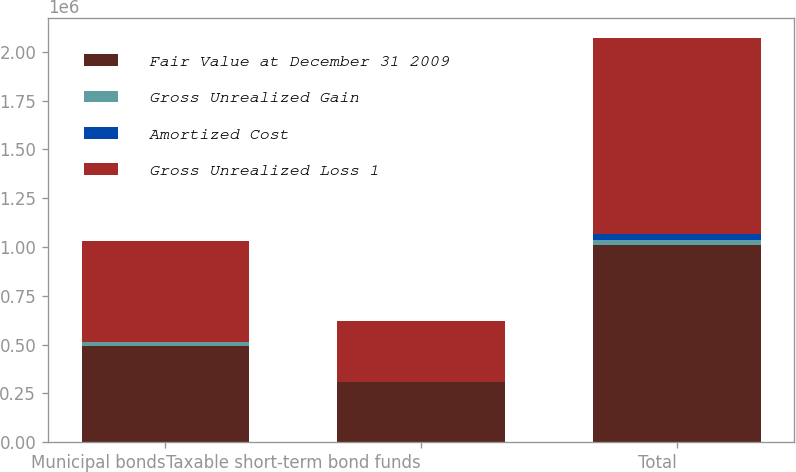Convert chart. <chart><loc_0><loc_0><loc_500><loc_500><stacked_bar_chart><ecel><fcel>Municipal bonds<fcel>Taxable short-term bond funds<fcel>Total<nl><fcel>Fair Value at December 31 2009<fcel>492245<fcel>305574<fcel>1.00966e+06<nl><fcel>Gross Unrealized Gain<fcel>22281<fcel>4474<fcel>26755<nl><fcel>Amortized Cost<fcel>196<fcel>76<fcel>32081<nl><fcel>Gross Unrealized Loss 1<fcel>514330<fcel>309972<fcel>1.00433e+06<nl></chart> 